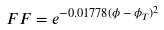Convert formula to latex. <formula><loc_0><loc_0><loc_500><loc_500>F F = e ^ { - 0 . 0 1 7 7 8 ( \phi \, - \, \phi _ { T } ) ^ { 2 } }</formula> 